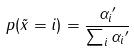<formula> <loc_0><loc_0><loc_500><loc_500>p ( \tilde { x } = i ) = \frac { { \alpha _ { i } } ^ { \prime } } { \sum _ { i } { \alpha _ { i } } ^ { \prime } }</formula> 